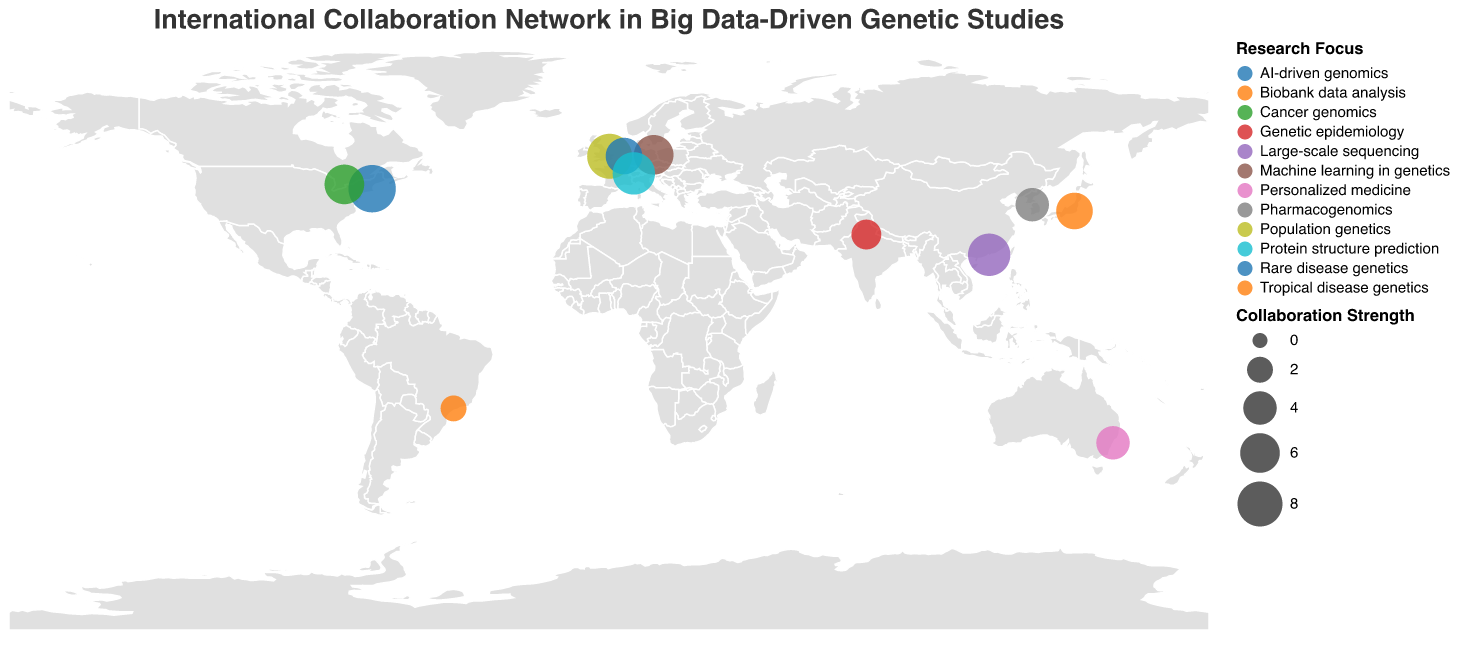What is the title of the figure? The title is prominently displayed at the top of the figure in larger font size.
Answer: International Collaboration Network in Big Data-Driven Genetic Studies What is the collaboration strength for Harvard Medical School? Look for the circle representing Harvard Medical School on the map and check the tooltip or legend information.
Answer: 9 Which research focus has the highest collaboration strength? Identify the circle with the largest size on the map and check its associated research focus from the tooltip.
Answer: AI-driven genomics How many collaborators are shown on the map? Count the number of circles plotted on the map as each circle represents a collaborator.
Answer: 12 Which collaborators in the figure are from Europe? Look for countries in Europe and identify their collaborators from the tooltip information.
Answer: Wellcome Sanger Institute (UK), Max Planck Institute for Molecular Genetics (Germany), Leiden University Medical Center (Netherlands), Swiss Institute of Bioinformatics (Switzerland) What is the median collaboration strength among the listed collaborators? Extract the collaboration strengths from all collaborators, sort them in ascending order, and find the middle value. The sorted strengths are (2, 3, 4, 4, 5, 5, 6, 6, 7, 7, 8, 9), so the median is the average of the 6th and 7th values: (5 + 6)/2.
Answer: 5.5 Which collaborator in Asia focuses on Pharmacogenomics? Identify circles located in Asia, then use the tooltip to find the research focus related to Pharmacogenomics.
Answer: Seoul National University (South Korea) What is the difference in collaboration strength between the collaborator from the USA and the one from Brazil? Identify the collaboration strengths for Harvard Medical School in the USA and the University of São Paulo in Brazil from the tooltip: USA (9) and Brazil (2). The difference is 9 - 2.
Answer: 7 Which two collaborators have the same collaboration strength and belong to different continents? Look for pairs of circles with the same size and check their tooltips for collaboration strength and location. For example, Max Planck Institute for Molecular Genetics (Germany) and Ontario Institute for Cancer Research (Canada) both have a strength of 6.
Answer: Max Planck Institute for Molecular Genetics and Ontario Institute for Cancer Research Which country in the figure focuses on Biobank data analysis? Check the tooltips of all circles to find the research focus related to Biobank data analysis.
Answer: Japan 